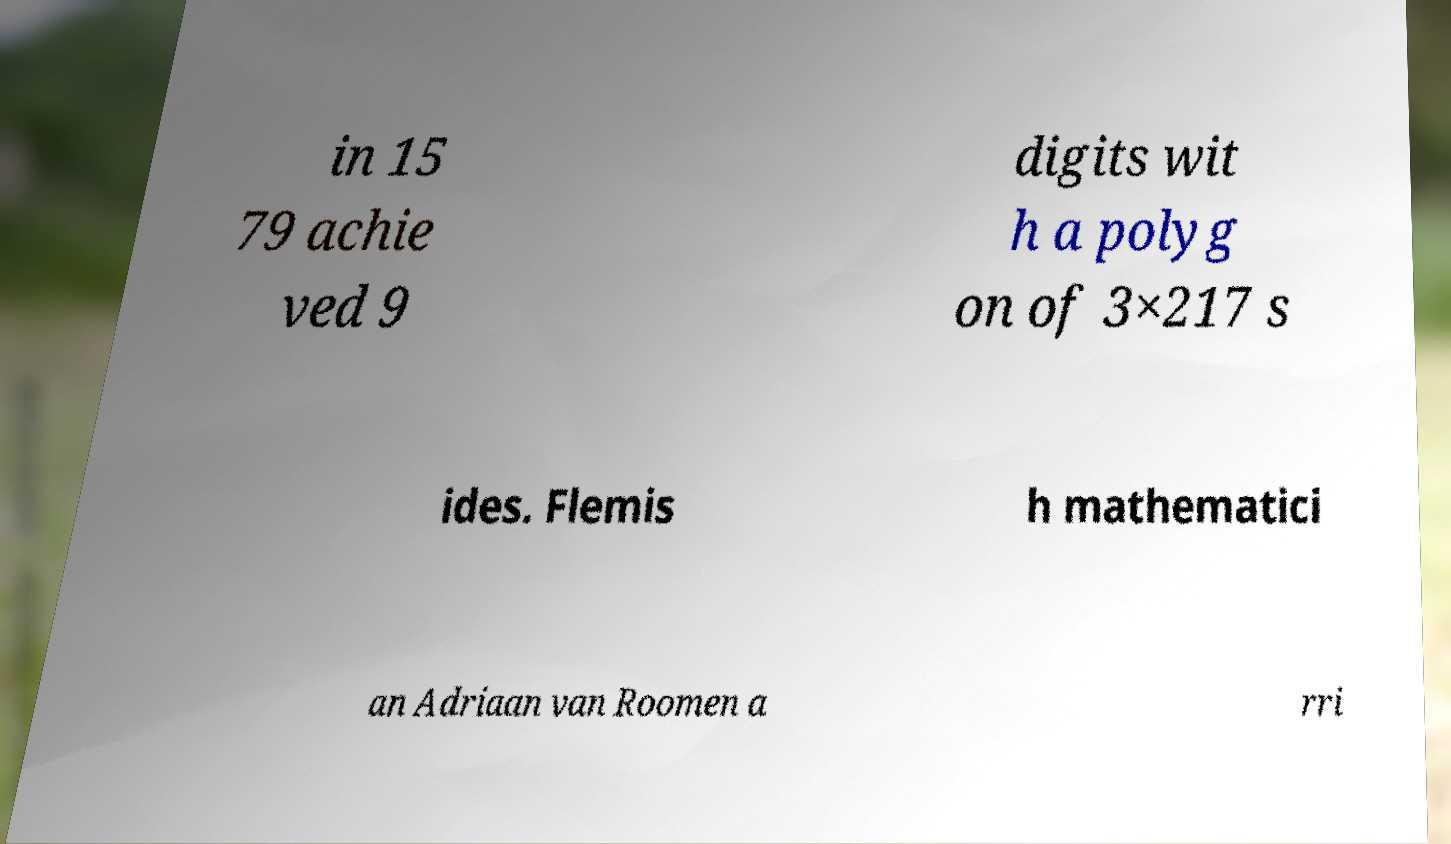I need the written content from this picture converted into text. Can you do that? in 15 79 achie ved 9 digits wit h a polyg on of 3×217 s ides. Flemis h mathematici an Adriaan van Roomen a rri 